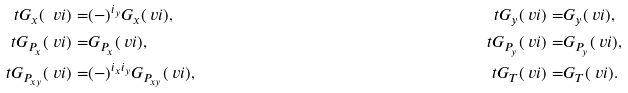<formula> <loc_0><loc_0><loc_500><loc_500>\ t G _ { x } ( \ v i ) = & ( - ) ^ { i _ { y } } G _ { x } ( \ v i ) , & \ t G _ { y } ( \ v i ) = & G _ { y } ( \ v i ) , \\ \ t G _ { P _ { x } } ( \ v i ) = & G _ { P _ { x } } ( \ v i ) , & \ t G _ { P _ { y } } ( \ v i ) = & G _ { P _ { y } } ( \ v i ) , \\ \ t G _ { P _ { x y } } ( \ v i ) = & ( - ) ^ { i _ { x } i _ { y } } G _ { P _ { x y } } ( \ v i ) , & \ t G _ { T } ( \ v i ) = & G _ { T } ( \ v i ) .</formula> 